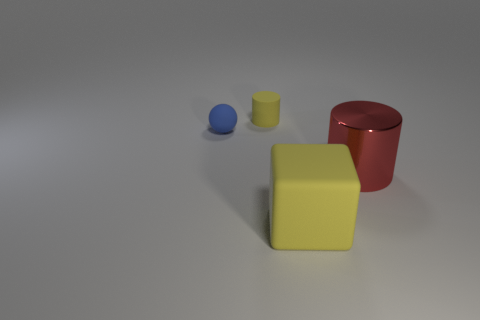What number of things are there?
Provide a short and direct response. 4. There is a shiny object; is it the same shape as the yellow thing behind the big red object?
Keep it short and to the point. Yes. How many things are small blue metal spheres or objects that are right of the small cylinder?
Your answer should be compact. 2. There is another yellow object that is the same shape as the metallic thing; what is its material?
Offer a very short reply. Rubber. Is the shape of the tiny object that is in front of the tiny yellow rubber thing the same as  the tiny yellow rubber thing?
Offer a very short reply. No. Is the number of blue things that are on the right side of the large red shiny thing less than the number of big yellow matte objects that are in front of the yellow cylinder?
Provide a short and direct response. Yes. What number of other things are there of the same shape as the big red object?
Keep it short and to the point. 1. There is a cylinder right of the thing in front of the large thing on the right side of the large yellow thing; what size is it?
Provide a succinct answer. Large. What number of cyan objects are either big matte cubes or big metallic objects?
Keep it short and to the point. 0. What shape is the object that is in front of the large object to the right of the yellow block?
Your response must be concise. Cube. 